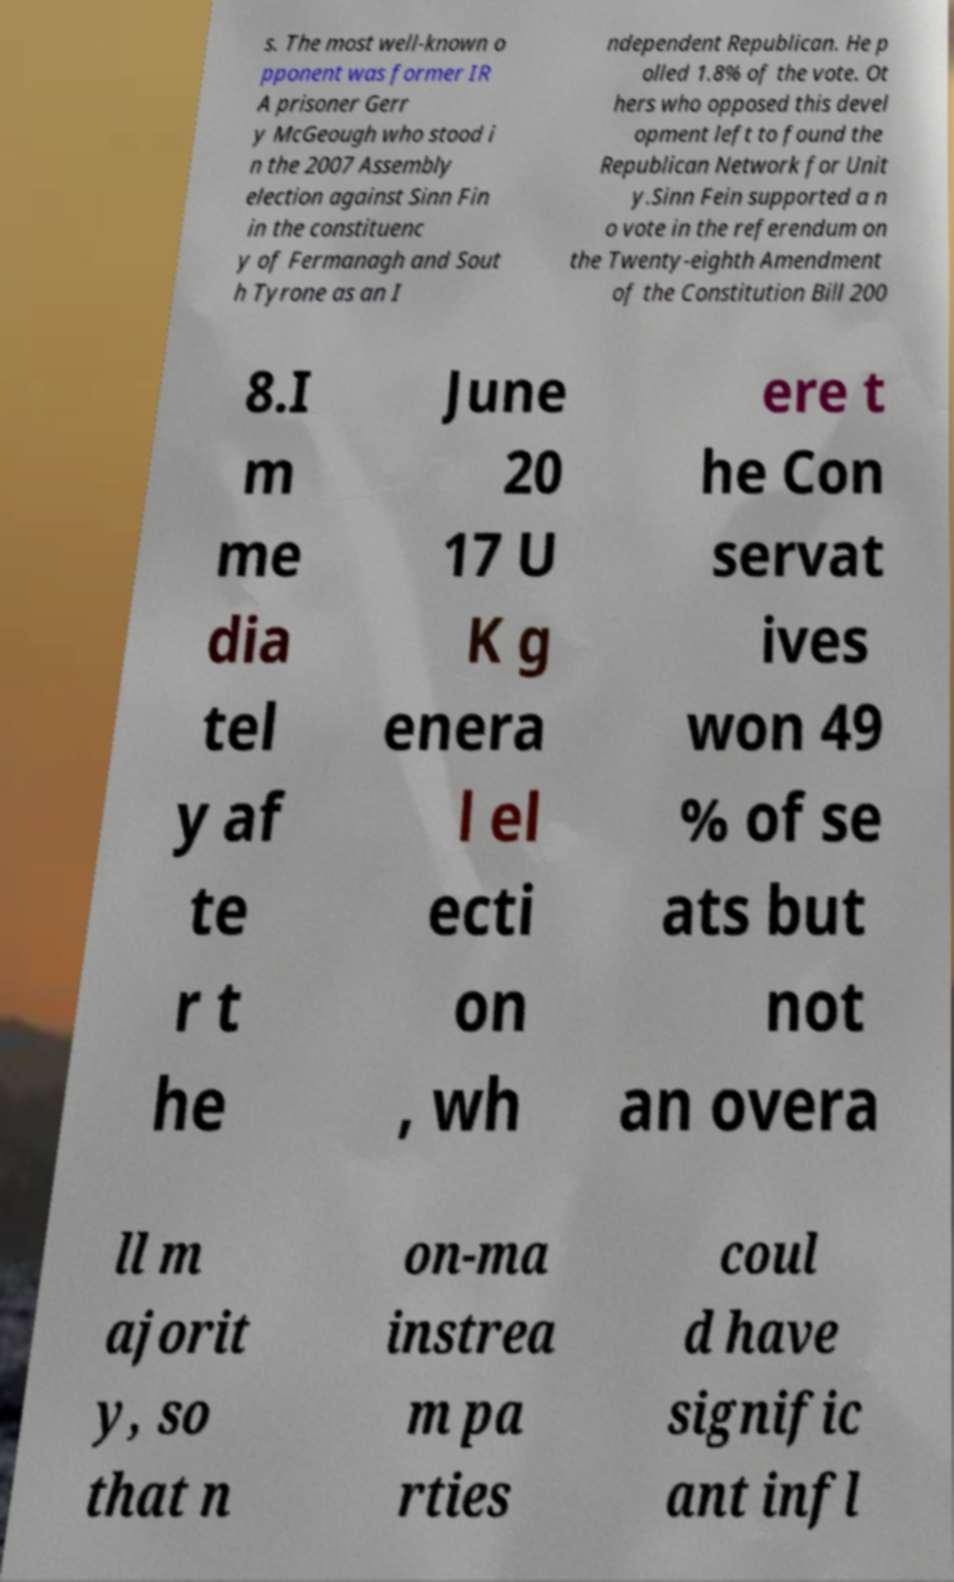Could you extract and type out the text from this image? s. The most well-known o pponent was former IR A prisoner Gerr y McGeough who stood i n the 2007 Assembly election against Sinn Fin in the constituenc y of Fermanagh and Sout h Tyrone as an I ndependent Republican. He p olled 1.8% of the vote. Ot hers who opposed this devel opment left to found the Republican Network for Unit y.Sinn Fein supported a n o vote in the referendum on the Twenty-eighth Amendment of the Constitution Bill 200 8.I m me dia tel y af te r t he June 20 17 U K g enera l el ecti on , wh ere t he Con servat ives won 49 % of se ats but not an overa ll m ajorit y, so that n on-ma instrea m pa rties coul d have signific ant infl 